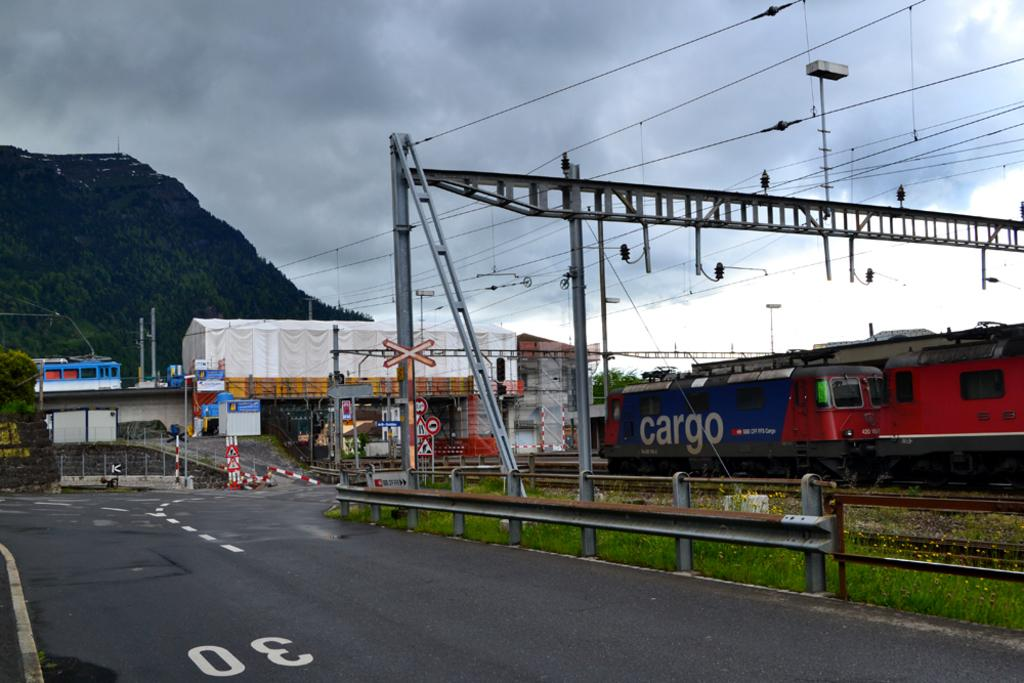What is the main subject of the image? The main subject of the image is a train. Where is the train located in the image? The train is on a railway track. What other structures can be seen in the image? There is a bridge, sign boards, and poles in the image. What type of vegetation is present in the image? There are trees in the image. How would you describe the weather in the image? The sky is cloudy in the image. What type of farm animals can be seen grazing near the train in the image? There are no farm animals present in the image; it features a train on a railway track with a bridge, sign boards, trees, poles, and a cloudy sky. 